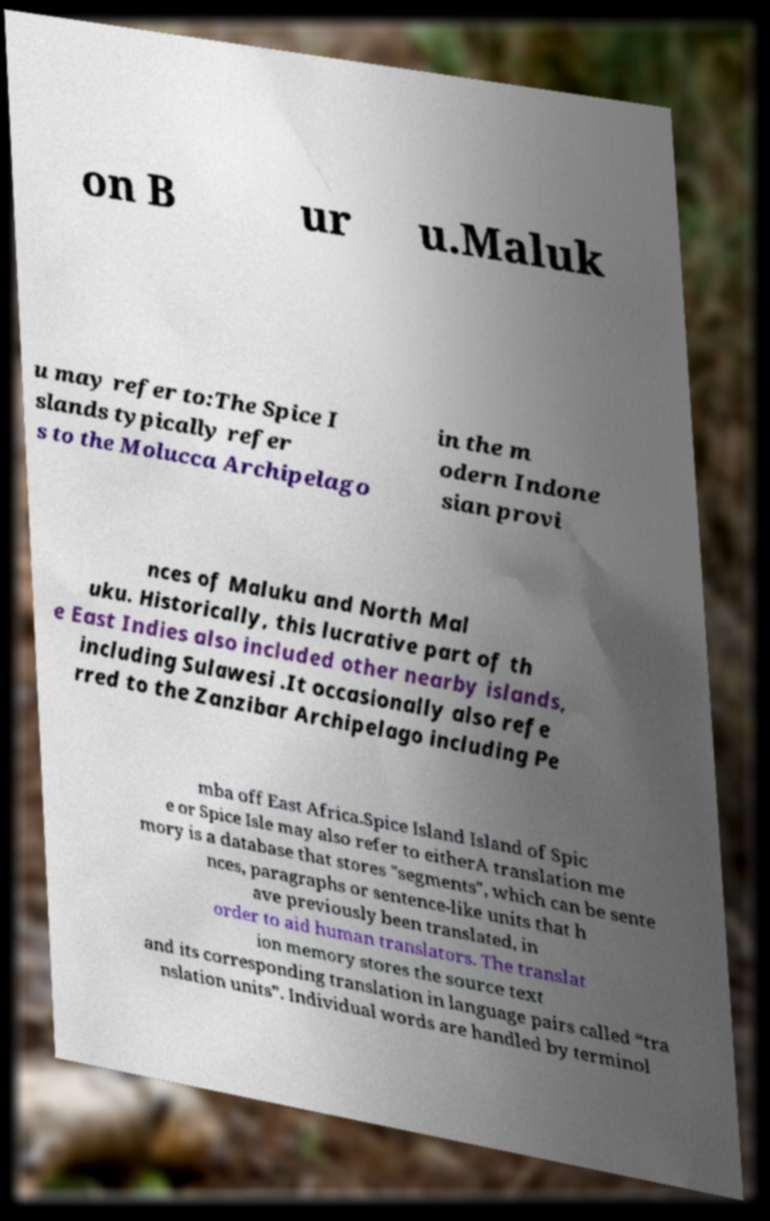For documentation purposes, I need the text within this image transcribed. Could you provide that? on B ur u.Maluk u may refer to:The Spice I slands typically refer s to the Molucca Archipelago in the m odern Indone sian provi nces of Maluku and North Mal uku. Historically, this lucrative part of th e East Indies also included other nearby islands, including Sulawesi .It occasionally also refe rred to the Zanzibar Archipelago including Pe mba off East Africa.Spice Island Island of Spic e or Spice Isle may also refer to eitherA translation me mory is a database that stores "segments", which can be sente nces, paragraphs or sentence-like units that h ave previously been translated, in order to aid human translators. The translat ion memory stores the source text and its corresponding translation in language pairs called “tra nslation units”. Individual words are handled by terminol 